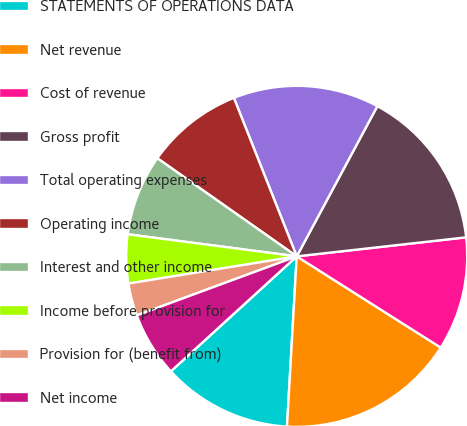<chart> <loc_0><loc_0><loc_500><loc_500><pie_chart><fcel>STATEMENTS OF OPERATIONS DATA<fcel>Net revenue<fcel>Cost of revenue<fcel>Gross profit<fcel>Total operating expenses<fcel>Operating income<fcel>Interest and other income<fcel>Income before provision for<fcel>Provision for (benefit from)<fcel>Net income<nl><fcel>12.31%<fcel>16.92%<fcel>10.77%<fcel>15.38%<fcel>13.85%<fcel>9.23%<fcel>7.69%<fcel>4.62%<fcel>3.08%<fcel>6.15%<nl></chart> 